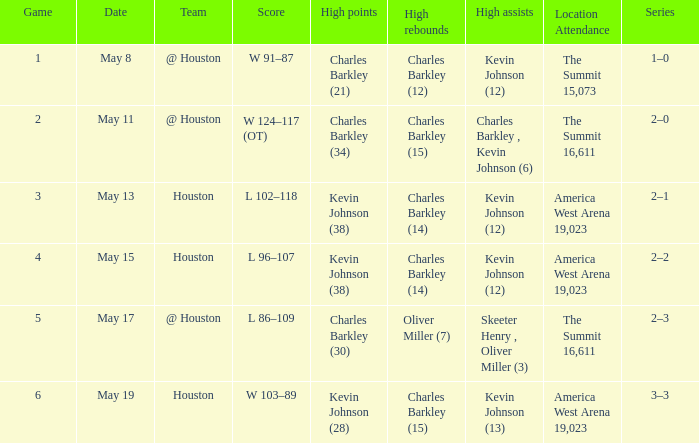Which series witnessed charles barkley (34) scoring the most points? 2–0. 